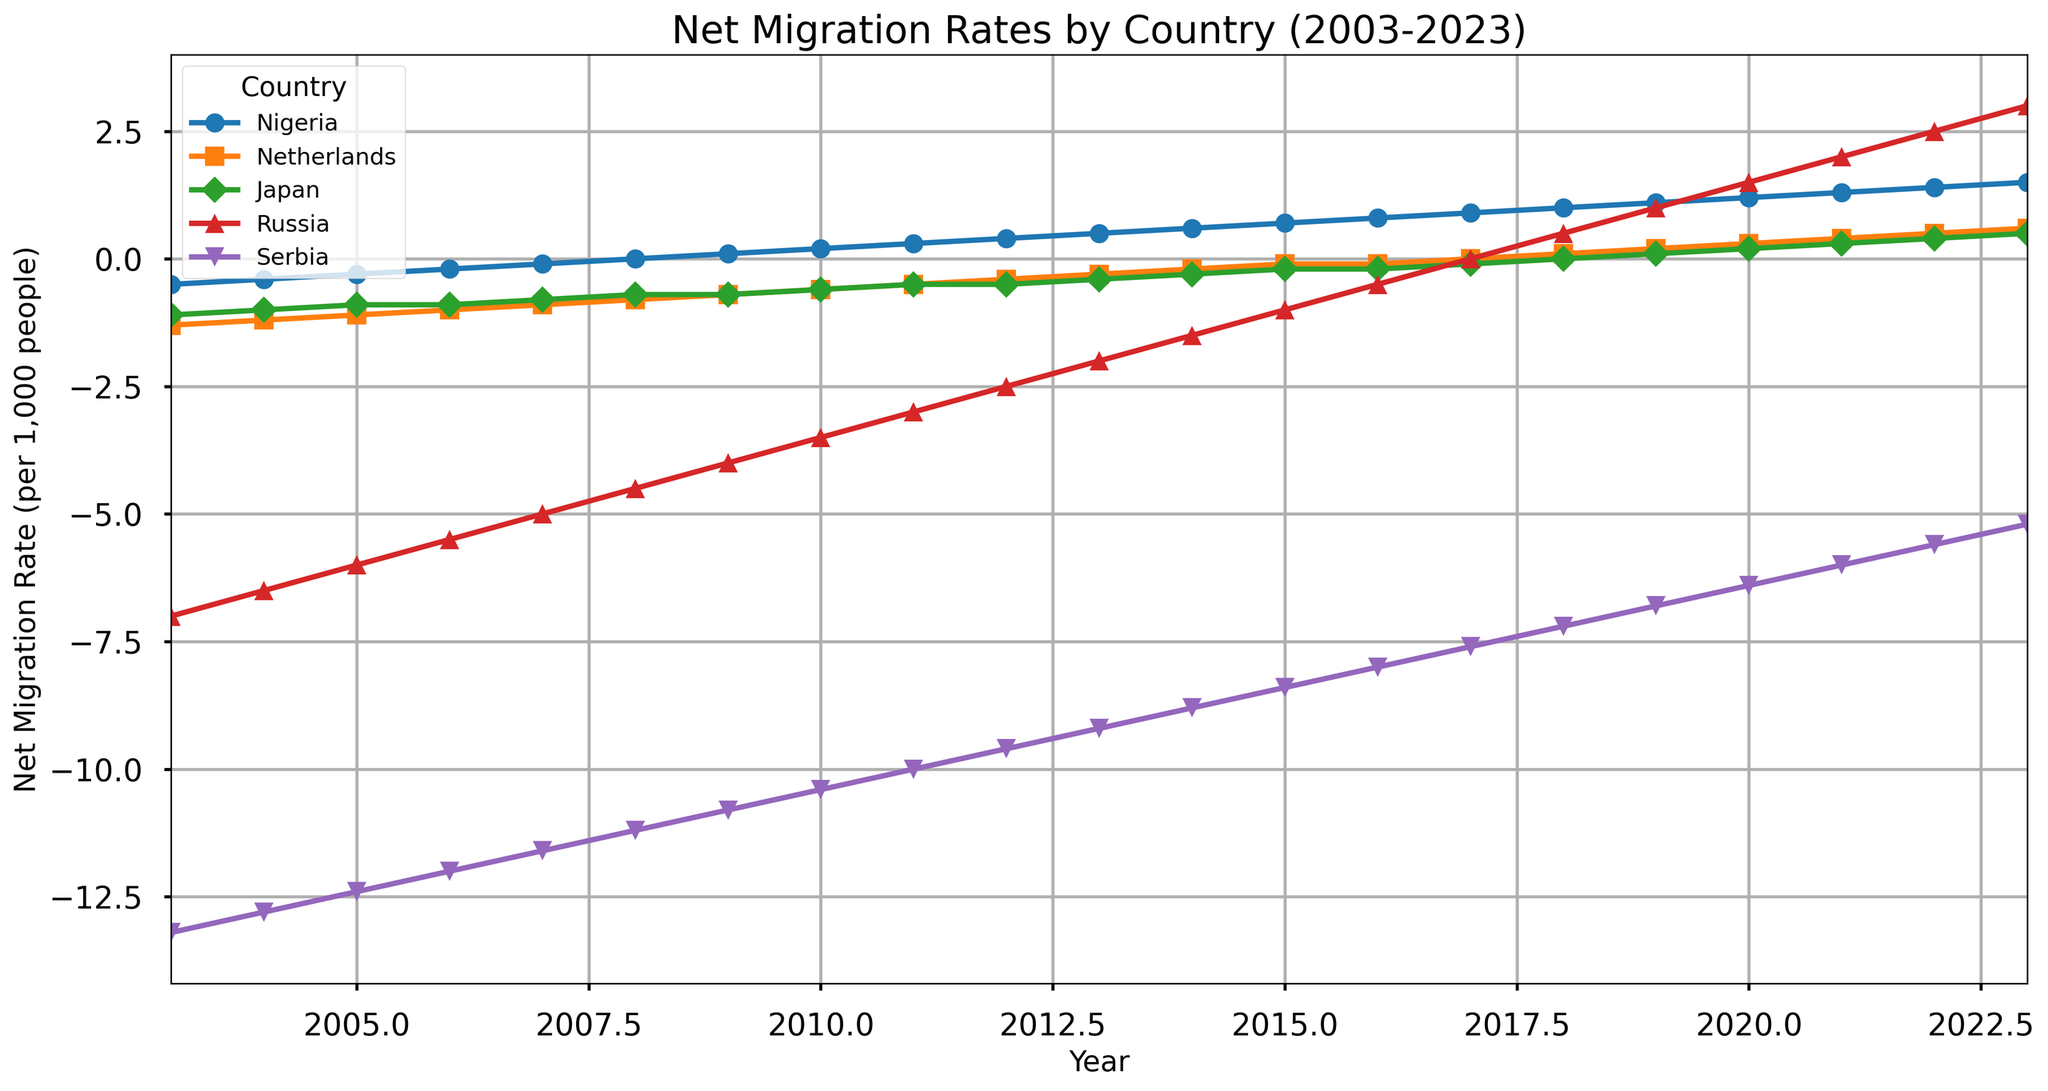What's the net migration rate trend for Nigeria over the 20-year period? Nigeria's net migration rate starts at -0.5 in 2003 and increases steadily to 1.5 in 2023. This indicates a positive trend in net migration for Nigeria over the period.
Answer: Increasing Did the net migration rate for Japan ever become positive between 2003 and 2023? The net migration rate for Japan steadily decreased from -1.1 in 2003 and became zero in 2018. It then turned positive to 0.5 by 2023.
Answer: Yes Which country had the steepest decline in net migration rate over the period? Serbia had the steepest decline, with the net migration rate changing from -13.2 in 2003 to -5.2 in 2023, indicating a considerable migration rate decrease compared to other countries.
Answer: Serbia In which year did Russia's net migration rate become positive? Russia's net migration rate became positive in 2017, transitioning from a negative value in previous years.
Answer: 2017 Compare the net migration rates of the Netherlands and Serbia in 2015. Which country had a higher rate? In 2015, the Netherlands had a rate of -0.1, whereas Serbia had -8.4, so the Netherlands had a higher net migration rate.
Answer: Netherlands What is the average net migration rate of the Netherlands over the first five years (2003-2007)? Average rate = sum of rates from 2003 to 2007 / number of years = (-1.3 - 1.2 - 1.1 - 1.0 - 0.9) / 5 = -5.5 / 5
Answer: -1.1 Which country had the highest net migration rate by 2023 and what was it? By 2023, Nigeria had the highest net migration rate, reaching 1.5.
Answer: Nigeria How did Russia's net migration rate in 2009 compare to Serbia's in the same year? In 2009, Russia had a net migration rate of -4, whereas Serbia's was -10.8. Russia's rate was significantly higher.
Answer: Russia's rate was higher By what factor did Nigeria's net migration rate change from 2010 to 2023? The net migration rate for Nigeria in 2010 was 0.2, and in 2023 it was 1.5. The change factor is 1.5 / 0.2 = 7.5.
Answer: 7.5 Which country had a stable net migration rate close to zero towards the end of the observed period? The Netherlands had a stable net migration rate close to zero, ending around 0.6 in 2023.
Answer: Netherlands 